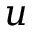<formula> <loc_0><loc_0><loc_500><loc_500>u</formula> 